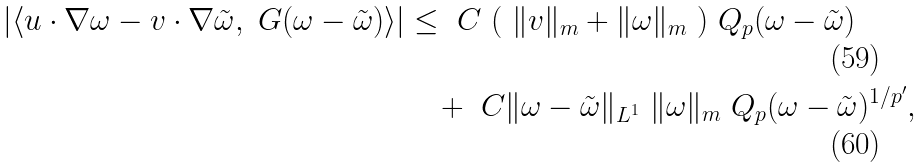Convert formula to latex. <formula><loc_0><loc_0><loc_500><loc_500>| \langle u \cdot \nabla \omega - v \cdot \nabla \tilde { \omega } , \ G ( \omega - \tilde { \omega } ) \rangle | & \leq \ C \ ( \ \| v \| _ { m } + \| \omega \| _ { m } \ ) \ Q _ { p } ( \omega - \tilde { \omega } ) \\ & \quad + \ C \| \omega - \tilde { \omega } \| _ { L ^ { 1 } } \ \| \omega \| _ { m } \ Q _ { p } ( \omega - \tilde { \omega } ) ^ { 1 / p ^ { \prime } } ,</formula> 